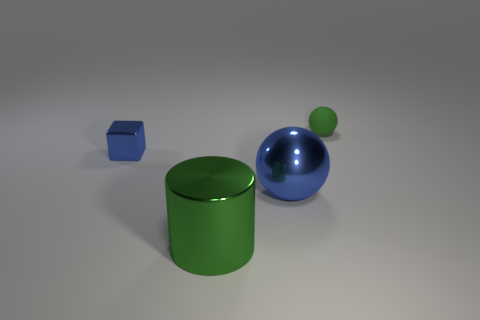There is a shiny thing in front of the big blue metallic ball; is its shape the same as the green object that is to the right of the cylinder?
Your answer should be compact. No. What size is the object that is the same color as the metal sphere?
Give a very brief answer. Small. What number of other objects are there of the same size as the block?
Your response must be concise. 1. There is a large metal cylinder; is it the same color as the object behind the small blue object?
Your response must be concise. Yes. Is the number of small balls that are to the left of the big green cylinder less than the number of large cylinders to the left of the blue cube?
Give a very brief answer. No. What is the color of the thing that is both behind the big blue metallic ball and on the right side of the big metal cylinder?
Keep it short and to the point. Green. There is a cylinder; is its size the same as the ball in front of the green rubber thing?
Offer a terse response. Yes. What shape is the green object that is left of the tiny rubber object?
Offer a terse response. Cylinder. Is there anything else that has the same material as the small block?
Provide a short and direct response. Yes. Is the number of big metallic things that are on the left side of the rubber sphere greater than the number of tiny red matte cylinders?
Ensure brevity in your answer.  Yes. 